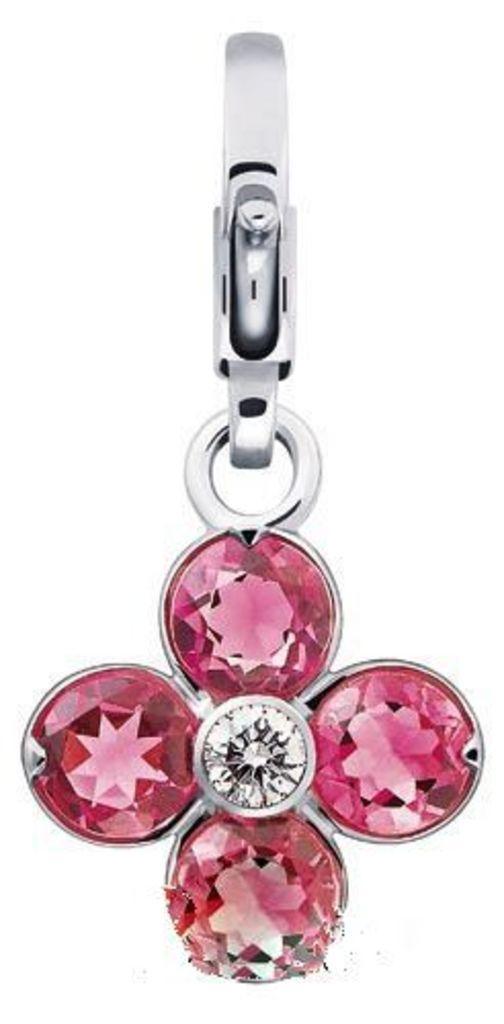In one or two sentences, can you explain what this image depicts? In the picture there is a locket with pink stones. 